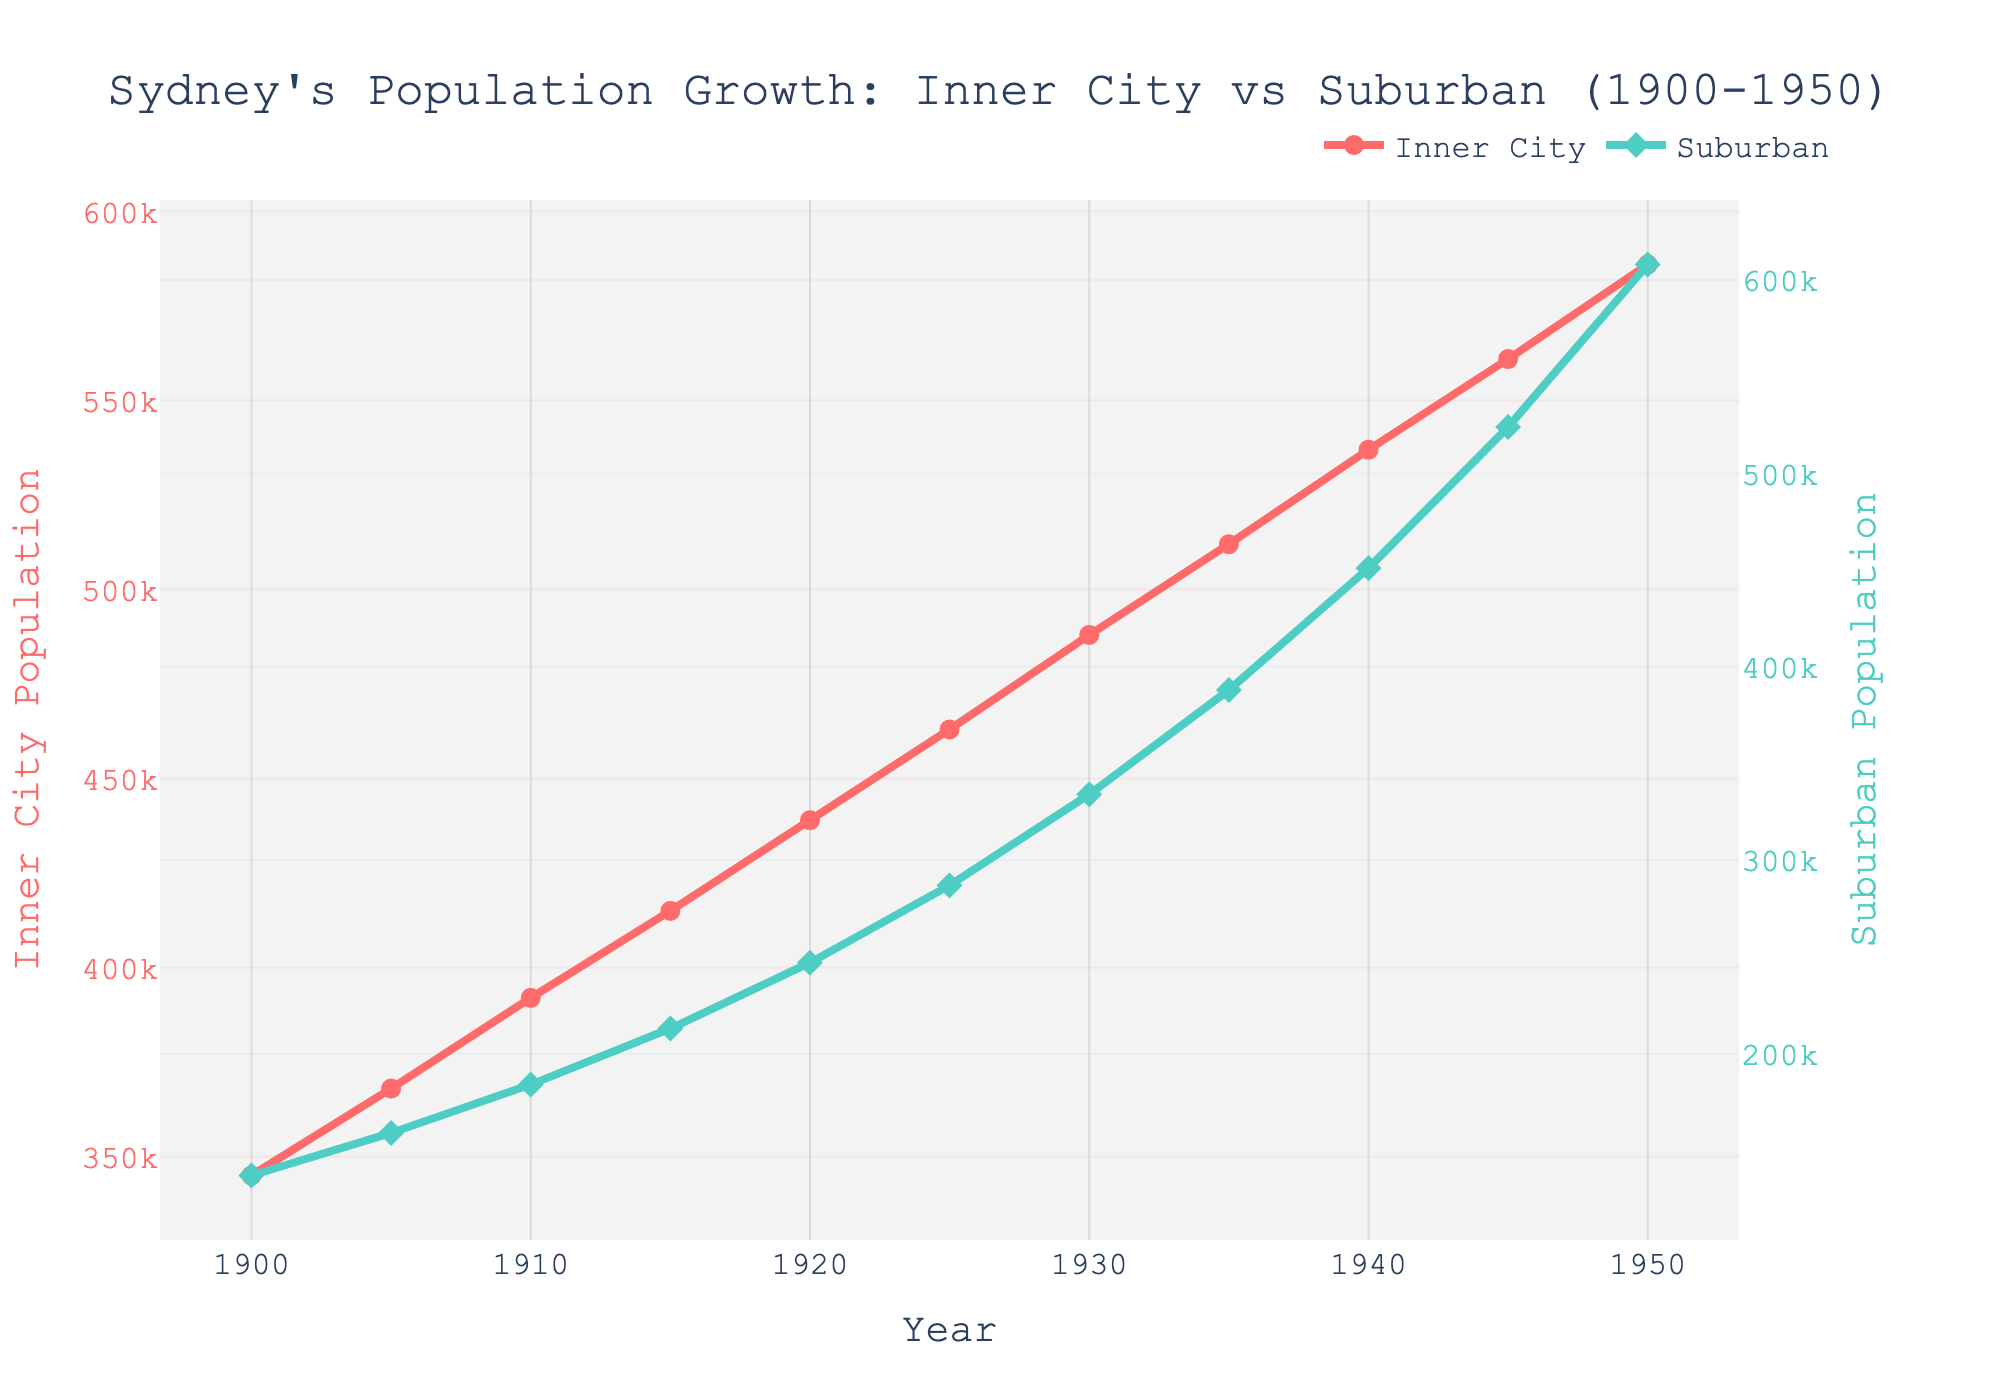What is the population growth in the inner city from 1900 to 1950? The inner city population in 1900 was 345,000, and by 1950 it was 586,000. The growth can be calculated as 586,000 - 345,000 = 241,000.
Answer: 241,000 By how much did the suburban population increase from 1930 to 1950? The suburban population in 1930 was 334,000, and in 1950 it was 608,000. The increase can be calculated as 608,000 - 334,000 = 274,000.
Answer: 274,000 Which area had the higher population in 1940, inner city or suburban? In 1940, the inner city population was 537,000, while the suburban population was 451,000. 537,000 is greater than 451,000, so the inner city had a higher population.
Answer: Inner city What is the overall trend observed for both inner city and suburban populations from 1900 to 1950? For both inner city and suburban populations, there is an increasing trend from 1900 to 1950. Both population lines show continuous upward movement throughout the years.
Answer: Increasing What is the difference between the suburban and inner city populations in 1925? The inner city population in 1925 was 463,000, and the suburban population was 287,000. The difference can be calculated as 463,000 - 287,000 = 176,000.
Answer: 176,000 What was the suburban population in 1920, and how does it compare to the inner city population in the same year? In 1920, the suburban population was 247,000, and the inner city population was 439,000. 439,000 is greater than 247,000, so the inner city had a higher population.
Answer: 439,000 is higher What are the colors representing the inner city and suburban population lines in the chart? The inner city population line is red, and the suburban population line is green. This is evident from the legends and the colors of the lines in the chart.
Answer: Red and green From 1900 to 1950, in which period did the inner city population see the largest increase? To find the largest increase, examine the differences between consecutive years for the inner city population. The largest increase was between 1945 and 1950, with a difference of 586,000 - 561,000 = 25,000.
Answer: 1945 to 1950 What was the population growth rate in suburban areas from 1905 to 1910? The suburban population in 1905 was 159,000, and in 1910 it was 184,000. The growth rate is calculated as (184,000 - 159,000) / 159,000 * 100% = 15.72%.
Answer: 15.72% In which year did the inner city population surpass the 500,000 mark? The inner city population surpassed the 500,000 mark in 1935 when it reached 512,000. This information can be read directly from the figure.
Answer: 1935 